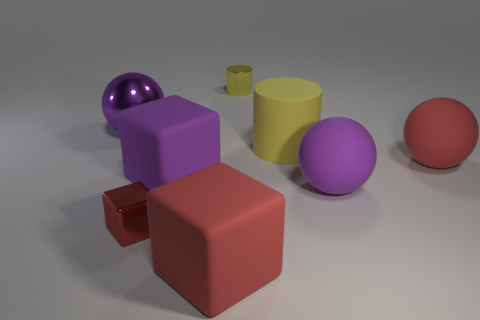Subtract 1 cubes. How many cubes are left? 2 Subtract all matte balls. How many balls are left? 1 Add 1 large spheres. How many objects exist? 9 Subtract all balls. How many objects are left? 5 Add 6 yellow metallic cylinders. How many yellow metallic cylinders exist? 7 Subtract 0 cyan spheres. How many objects are left? 8 Subtract all large cyan matte blocks. Subtract all small red metallic things. How many objects are left? 7 Add 4 matte cylinders. How many matte cylinders are left? 5 